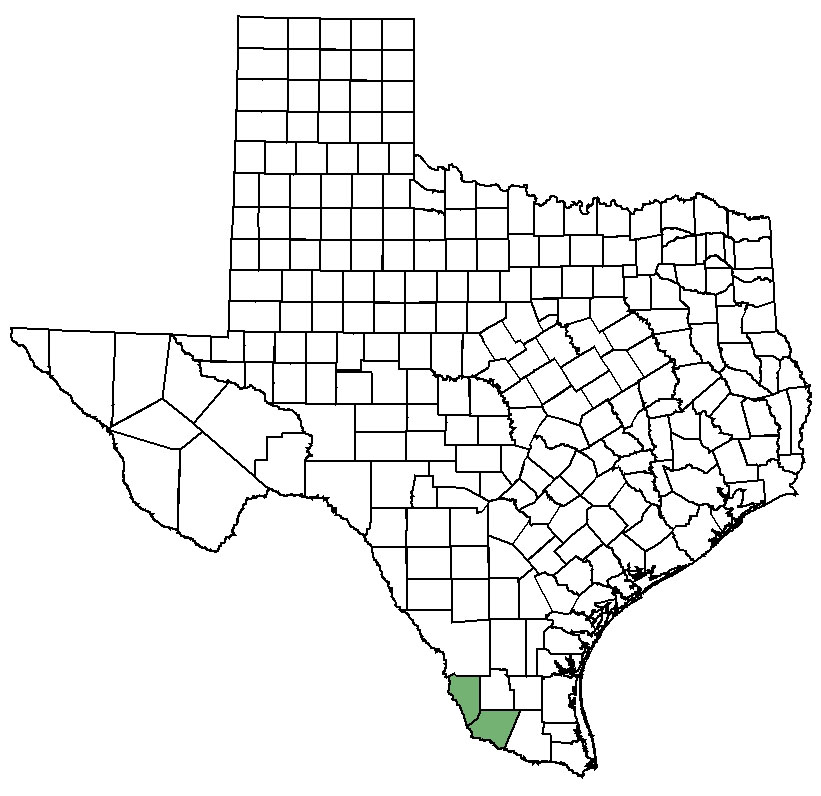What would be the impact of a severe drought on the highlighted county? A severe drought would have significant impacts on the highlighted county. As an area reliant on agriculture and livestock, water scarcity would challenge crop irrigation, leading to reduced yields and economic strain on farmers. Livestock would suffer from decreased water and forage availability, further affecting the rural economy. The natural habitat would experience stress, with native species facing survival challenges. Prolonged drought could also increase wildfire risks, threatening both land and communities. The county's socioeconomic structure would be tested as it adapts to these harsh conditions, potentially necessitating aid and innovative water conservation measures. 